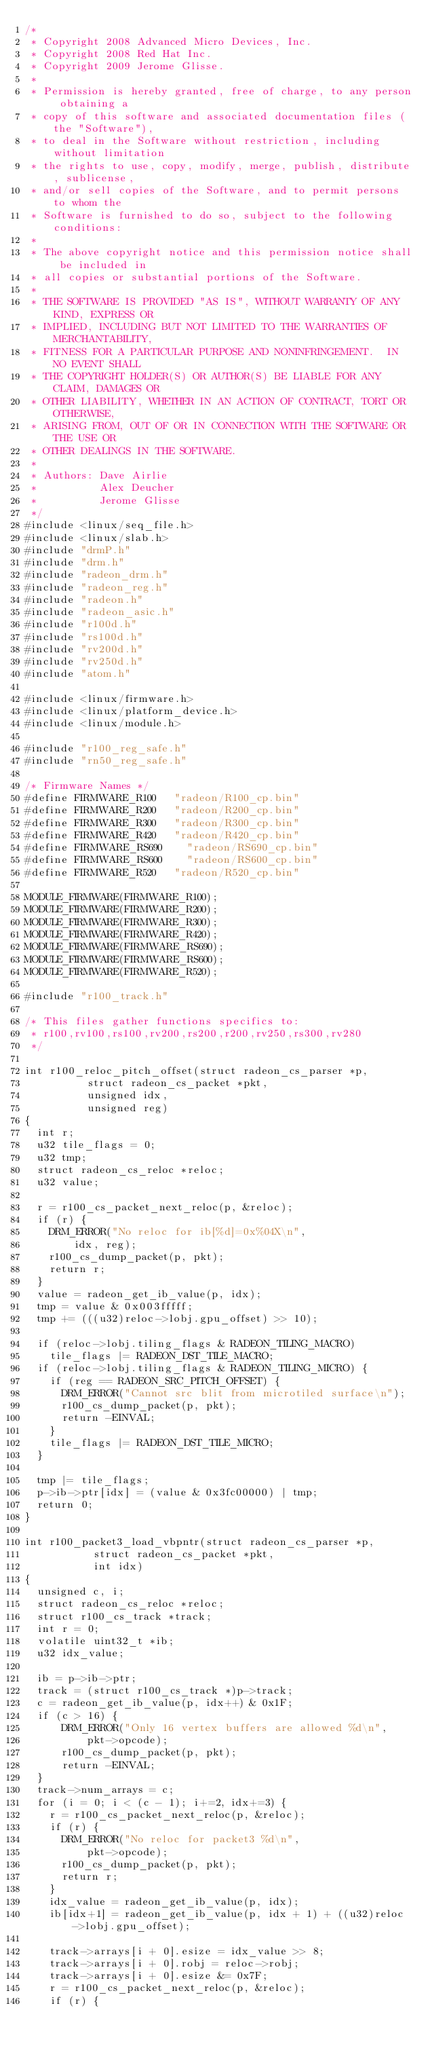Convert code to text. <code><loc_0><loc_0><loc_500><loc_500><_C_>/*
 * Copyright 2008 Advanced Micro Devices, Inc.
 * Copyright 2008 Red Hat Inc.
 * Copyright 2009 Jerome Glisse.
 *
 * Permission is hereby granted, free of charge, to any person obtaining a
 * copy of this software and associated documentation files (the "Software"),
 * to deal in the Software without restriction, including without limitation
 * the rights to use, copy, modify, merge, publish, distribute, sublicense,
 * and/or sell copies of the Software, and to permit persons to whom the
 * Software is furnished to do so, subject to the following conditions:
 *
 * The above copyright notice and this permission notice shall be included in
 * all copies or substantial portions of the Software.
 *
 * THE SOFTWARE IS PROVIDED "AS IS", WITHOUT WARRANTY OF ANY KIND, EXPRESS OR
 * IMPLIED, INCLUDING BUT NOT LIMITED TO THE WARRANTIES OF MERCHANTABILITY,
 * FITNESS FOR A PARTICULAR PURPOSE AND NONINFRINGEMENT.  IN NO EVENT SHALL
 * THE COPYRIGHT HOLDER(S) OR AUTHOR(S) BE LIABLE FOR ANY CLAIM, DAMAGES OR
 * OTHER LIABILITY, WHETHER IN AN ACTION OF CONTRACT, TORT OR OTHERWISE,
 * ARISING FROM, OUT OF OR IN CONNECTION WITH THE SOFTWARE OR THE USE OR
 * OTHER DEALINGS IN THE SOFTWARE.
 *
 * Authors: Dave Airlie
 *          Alex Deucher
 *          Jerome Glisse
 */
#include <linux/seq_file.h>
#include <linux/slab.h>
#include "drmP.h"
#include "drm.h"
#include "radeon_drm.h"
#include "radeon_reg.h"
#include "radeon.h"
#include "radeon_asic.h"
#include "r100d.h"
#include "rs100d.h"
#include "rv200d.h"
#include "rv250d.h"
#include "atom.h"

#include <linux/firmware.h>
#include <linux/platform_device.h>
#include <linux/module.h>

#include "r100_reg_safe.h"
#include "rn50_reg_safe.h"

/* Firmware Names */
#define FIRMWARE_R100		"radeon/R100_cp.bin"
#define FIRMWARE_R200		"radeon/R200_cp.bin"
#define FIRMWARE_R300		"radeon/R300_cp.bin"
#define FIRMWARE_R420		"radeon/R420_cp.bin"
#define FIRMWARE_RS690		"radeon/RS690_cp.bin"
#define FIRMWARE_RS600		"radeon/RS600_cp.bin"
#define FIRMWARE_R520		"radeon/R520_cp.bin"

MODULE_FIRMWARE(FIRMWARE_R100);
MODULE_FIRMWARE(FIRMWARE_R200);
MODULE_FIRMWARE(FIRMWARE_R300);
MODULE_FIRMWARE(FIRMWARE_R420);
MODULE_FIRMWARE(FIRMWARE_RS690);
MODULE_FIRMWARE(FIRMWARE_RS600);
MODULE_FIRMWARE(FIRMWARE_R520);

#include "r100_track.h"

/* This files gather functions specifics to:
 * r100,rv100,rs100,rv200,rs200,r200,rv250,rs300,rv280
 */

int r100_reloc_pitch_offset(struct radeon_cs_parser *p,
			    struct radeon_cs_packet *pkt,
			    unsigned idx,
			    unsigned reg)
{
	int r;
	u32 tile_flags = 0;
	u32 tmp;
	struct radeon_cs_reloc *reloc;
	u32 value;

	r = r100_cs_packet_next_reloc(p, &reloc);
	if (r) {
		DRM_ERROR("No reloc for ib[%d]=0x%04X\n",
			  idx, reg);
		r100_cs_dump_packet(p, pkt);
		return r;
	}
	value = radeon_get_ib_value(p, idx);
	tmp = value & 0x003fffff;
	tmp += (((u32)reloc->lobj.gpu_offset) >> 10);

	if (reloc->lobj.tiling_flags & RADEON_TILING_MACRO)
		tile_flags |= RADEON_DST_TILE_MACRO;
	if (reloc->lobj.tiling_flags & RADEON_TILING_MICRO) {
		if (reg == RADEON_SRC_PITCH_OFFSET) {
			DRM_ERROR("Cannot src blit from microtiled surface\n");
			r100_cs_dump_packet(p, pkt);
			return -EINVAL;
		}
		tile_flags |= RADEON_DST_TILE_MICRO;
	}

	tmp |= tile_flags;
	p->ib->ptr[idx] = (value & 0x3fc00000) | tmp;
	return 0;
}

int r100_packet3_load_vbpntr(struct radeon_cs_parser *p,
			     struct radeon_cs_packet *pkt,
			     int idx)
{
	unsigned c, i;
	struct radeon_cs_reloc *reloc;
	struct r100_cs_track *track;
	int r = 0;
	volatile uint32_t *ib;
	u32 idx_value;

	ib = p->ib->ptr;
	track = (struct r100_cs_track *)p->track;
	c = radeon_get_ib_value(p, idx++) & 0x1F;
	if (c > 16) {
	    DRM_ERROR("Only 16 vertex buffers are allowed %d\n",
		      pkt->opcode);
	    r100_cs_dump_packet(p, pkt);
	    return -EINVAL;
	}
	track->num_arrays = c;
	for (i = 0; i < (c - 1); i+=2, idx+=3) {
		r = r100_cs_packet_next_reloc(p, &reloc);
		if (r) {
			DRM_ERROR("No reloc for packet3 %d\n",
				  pkt->opcode);
			r100_cs_dump_packet(p, pkt);
			return r;
		}
		idx_value = radeon_get_ib_value(p, idx);
		ib[idx+1] = radeon_get_ib_value(p, idx + 1) + ((u32)reloc->lobj.gpu_offset);

		track->arrays[i + 0].esize = idx_value >> 8;
		track->arrays[i + 0].robj = reloc->robj;
		track->arrays[i + 0].esize &= 0x7F;
		r = r100_cs_packet_next_reloc(p, &reloc);
		if (r) {</code> 